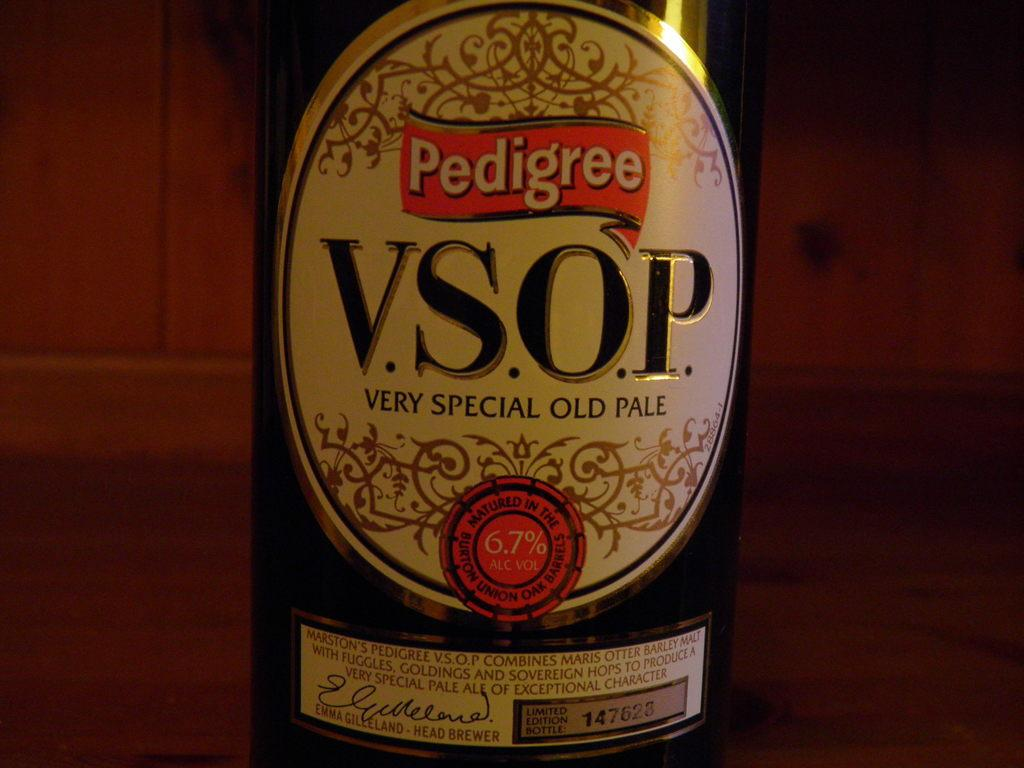Provide a one-sentence caption for the provided image. Pedigree is proud to offer a very special old pale also known as V.S.O.P. 